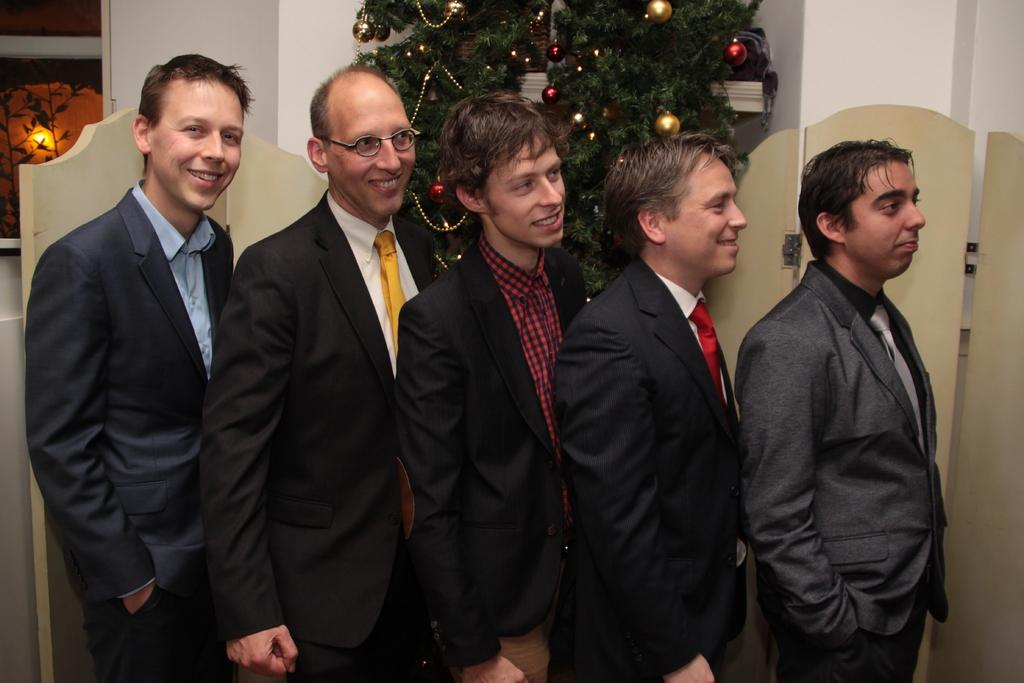How many people are present in the image? There are five people standing in the image. What can be seen in the background of the image? There are wooden boards and a tree decorated with balls and chains in the background of the image. Is there any structure or object attached to the wall in the background? Yes, there is a frame attached to the wall in the background of the image. What type of apple is being used as a pillow by one of the people in the image? There is no apple present in the image, and none of the people are using an apple as a pillow. 